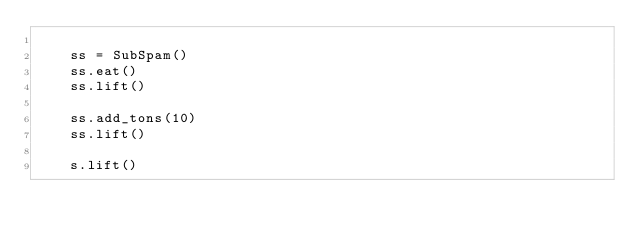<code> <loc_0><loc_0><loc_500><loc_500><_Cython_>
    ss = SubSpam()
    ss.eat()
    ss.lift()

    ss.add_tons(10)
    ss.lift()

    s.lift()
</code> 